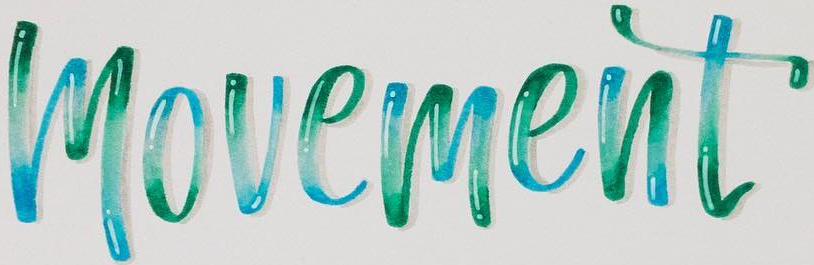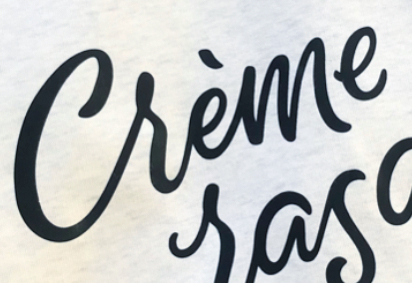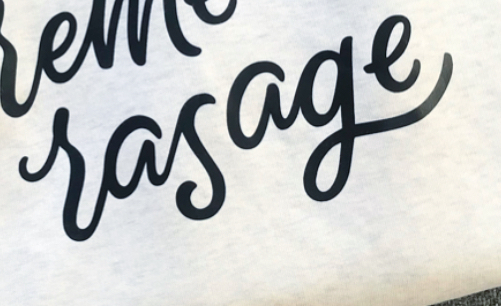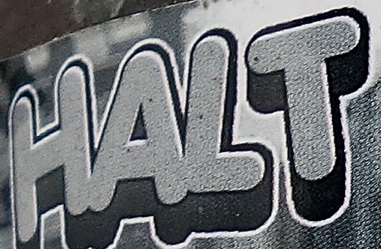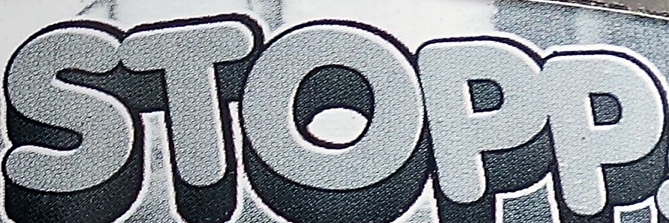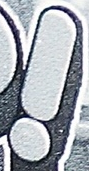What text appears in these images from left to right, separated by a semicolon? movement; Crème; rasage; HALT; STOPP; ! 